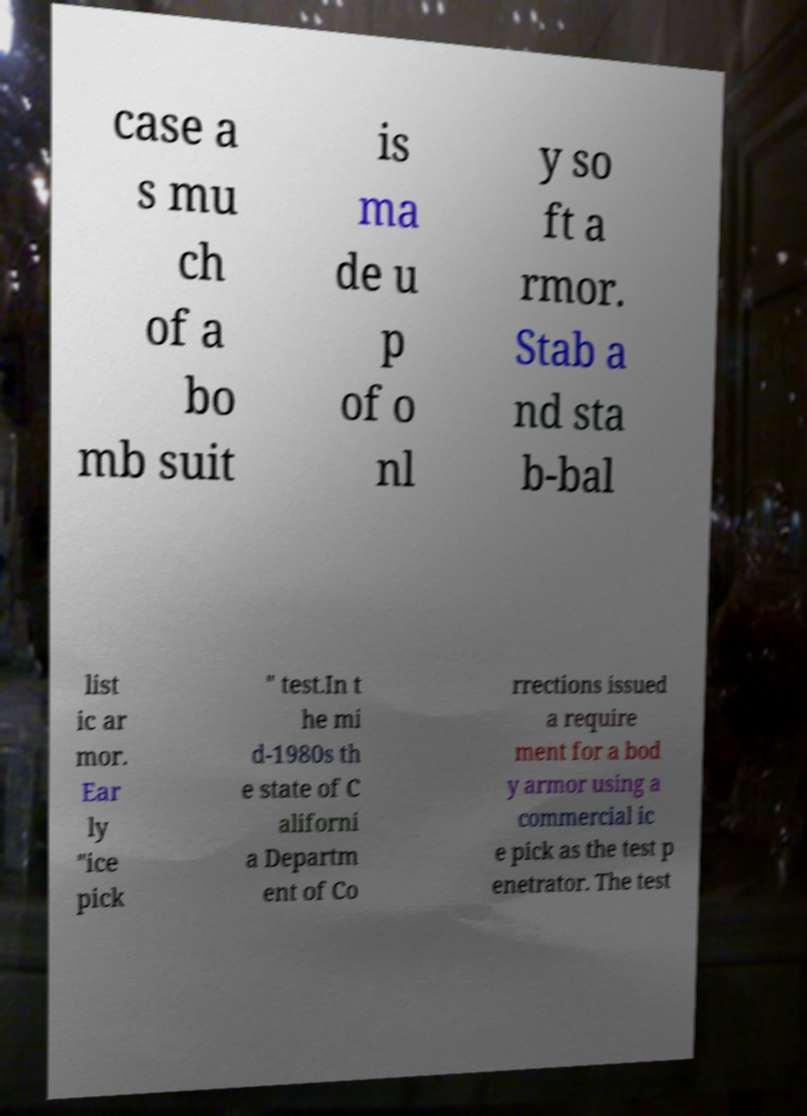Can you accurately transcribe the text from the provided image for me? case a s mu ch of a bo mb suit is ma de u p of o nl y so ft a rmor. Stab a nd sta b-bal list ic ar mor. Ear ly "ice pick " test.In t he mi d-1980s th e state of C aliforni a Departm ent of Co rrections issued a require ment for a bod y armor using a commercial ic e pick as the test p enetrator. The test 